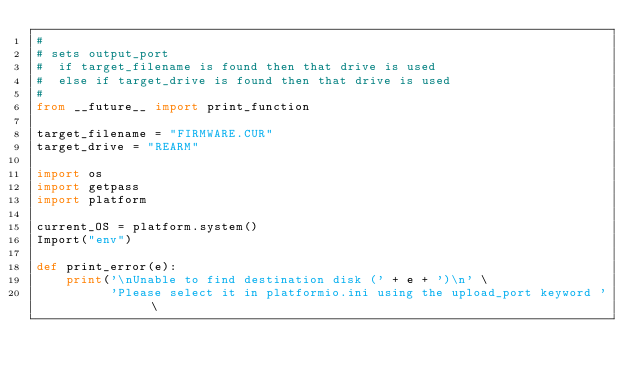Convert code to text. <code><loc_0><loc_0><loc_500><loc_500><_Python_>#
# sets output_port
#  if target_filename is found then that drive is used
#  else if target_drive is found then that drive is used
#
from __future__ import print_function

target_filename = "FIRMWARE.CUR"
target_drive = "REARM"

import os
import getpass
import platform

current_OS = platform.system()
Import("env")

def print_error(e):
    print('\nUnable to find destination disk (' + e + ')\n' \
          'Please select it in platformio.ini using the upload_port keyword ' \</code> 